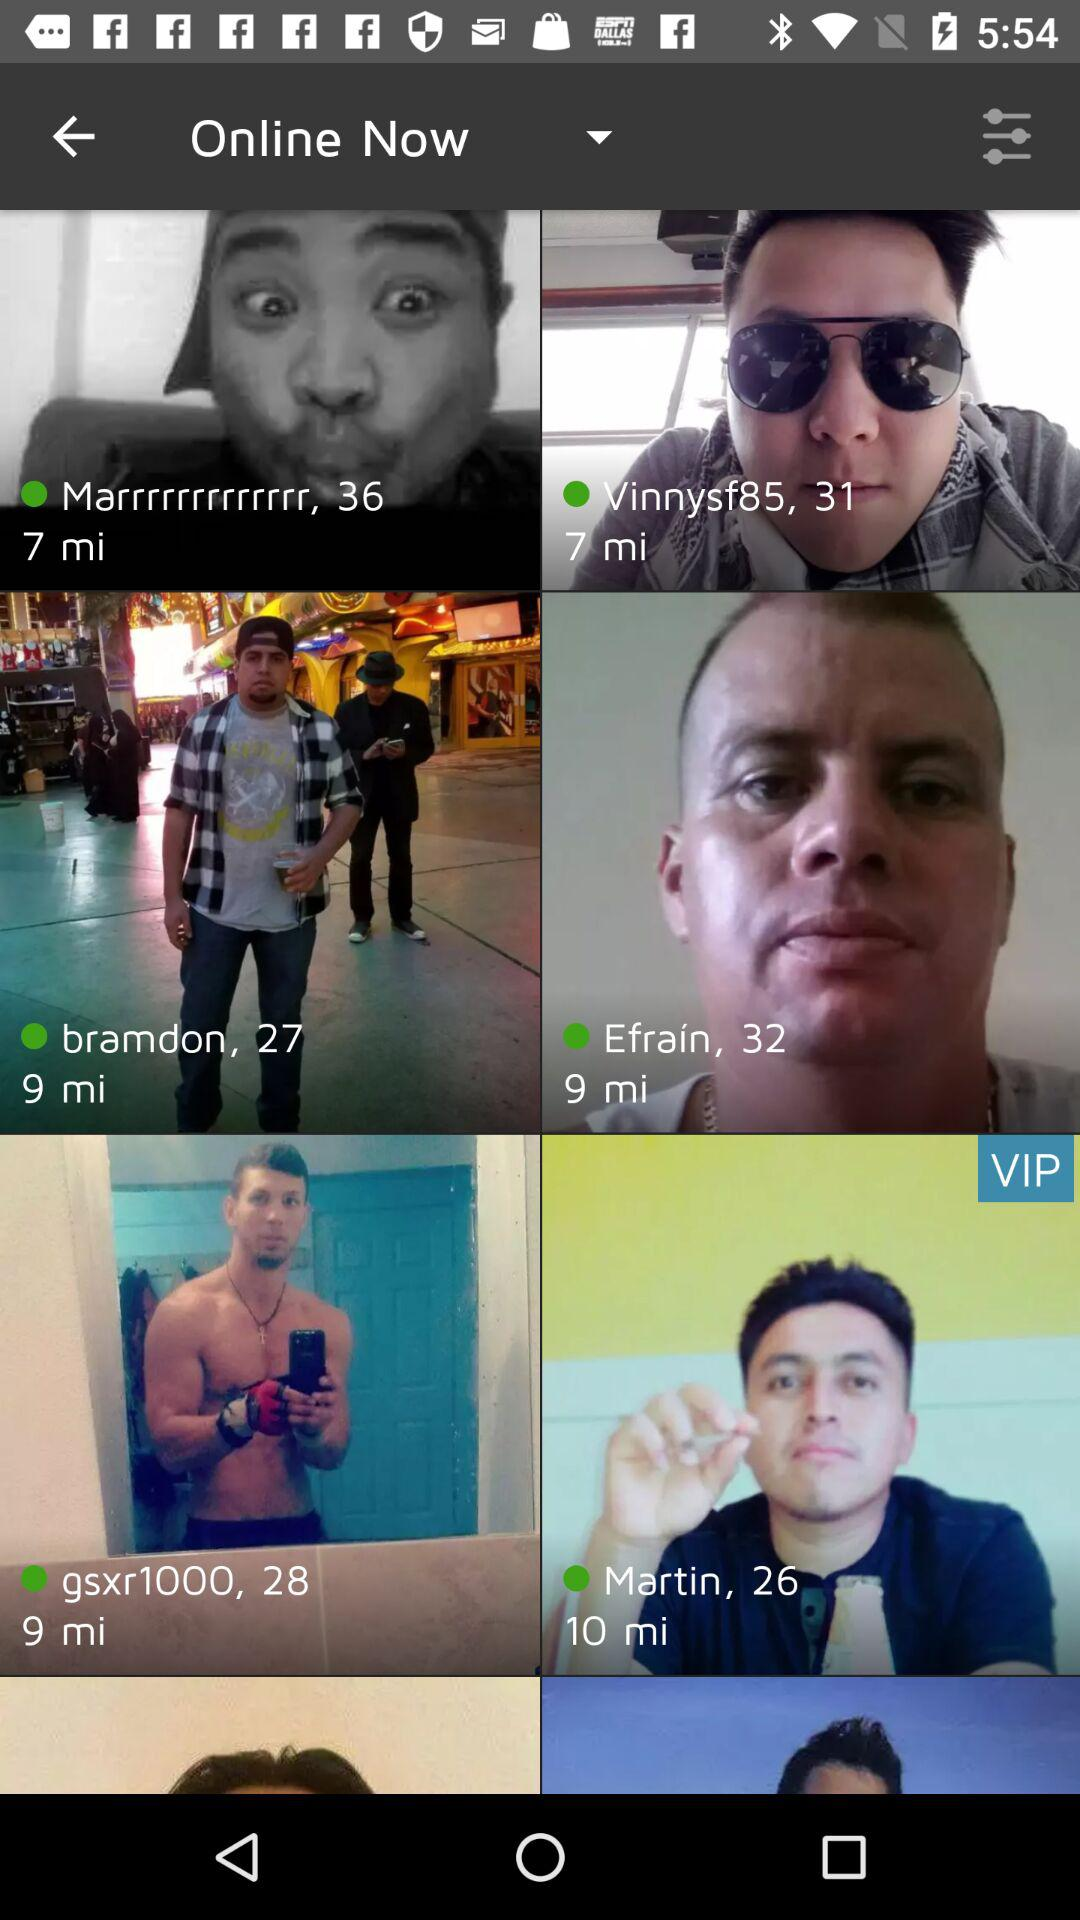Is Efrain online or not?
Answer the question using a single word or phrase. Efrain is online. 